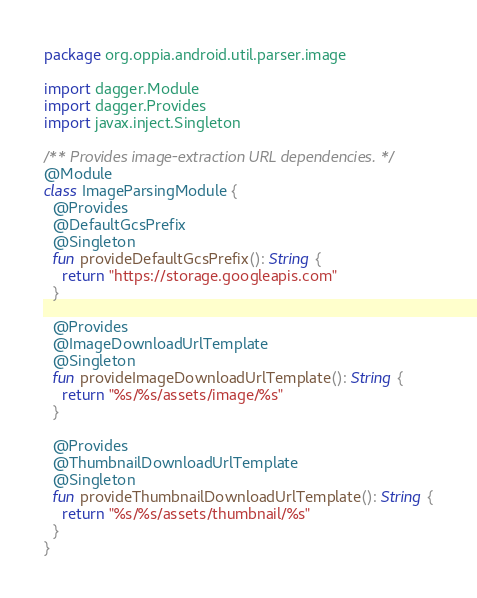<code> <loc_0><loc_0><loc_500><loc_500><_Kotlin_>package org.oppia.android.util.parser.image

import dagger.Module
import dagger.Provides
import javax.inject.Singleton

/** Provides image-extraction URL dependencies. */
@Module
class ImageParsingModule {
  @Provides
  @DefaultGcsPrefix
  @Singleton
  fun provideDefaultGcsPrefix(): String {
    return "https://storage.googleapis.com"
  }

  @Provides
  @ImageDownloadUrlTemplate
  @Singleton
  fun provideImageDownloadUrlTemplate(): String {
    return "%s/%s/assets/image/%s"
  }

  @Provides
  @ThumbnailDownloadUrlTemplate
  @Singleton
  fun provideThumbnailDownloadUrlTemplate(): String {
    return "%s/%s/assets/thumbnail/%s"
  }
}
</code> 